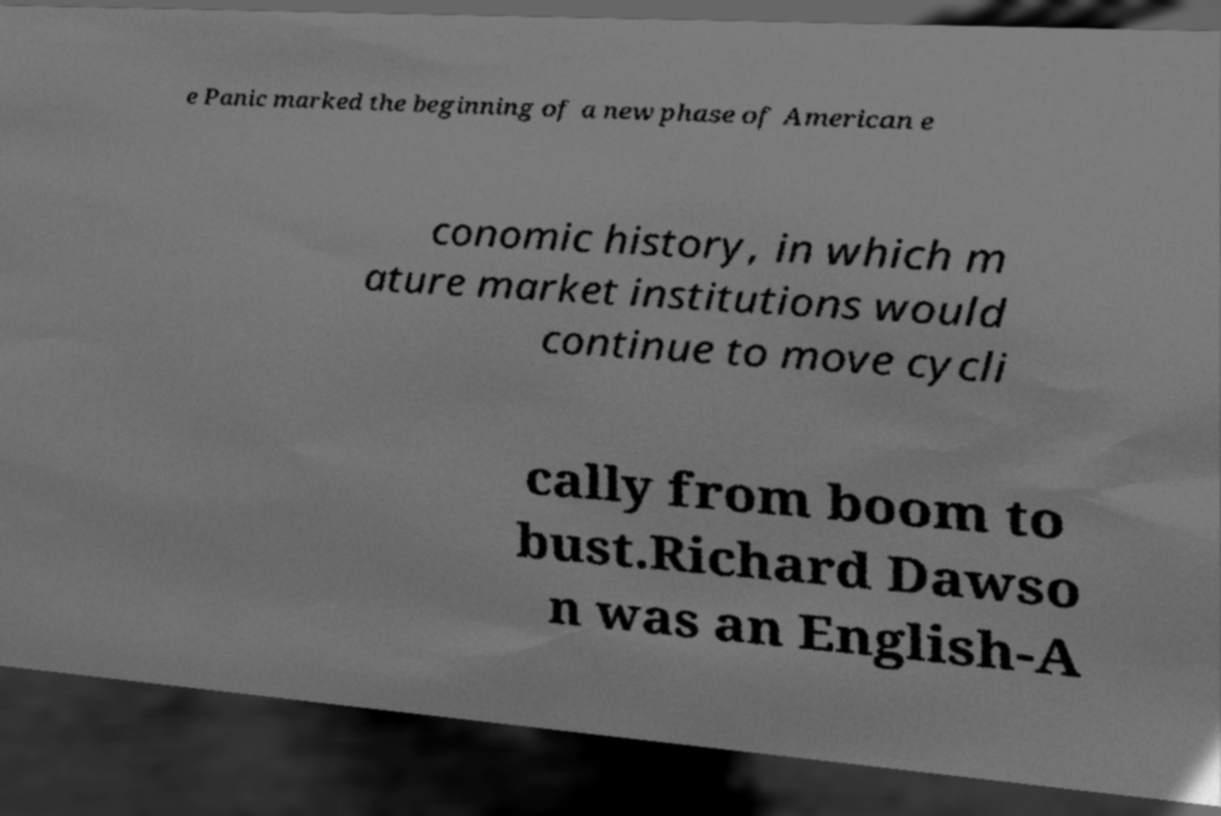What messages or text are displayed in this image? I need them in a readable, typed format. e Panic marked the beginning of a new phase of American e conomic history, in which m ature market institutions would continue to move cycli cally from boom to bust.Richard Dawso n was an English-A 